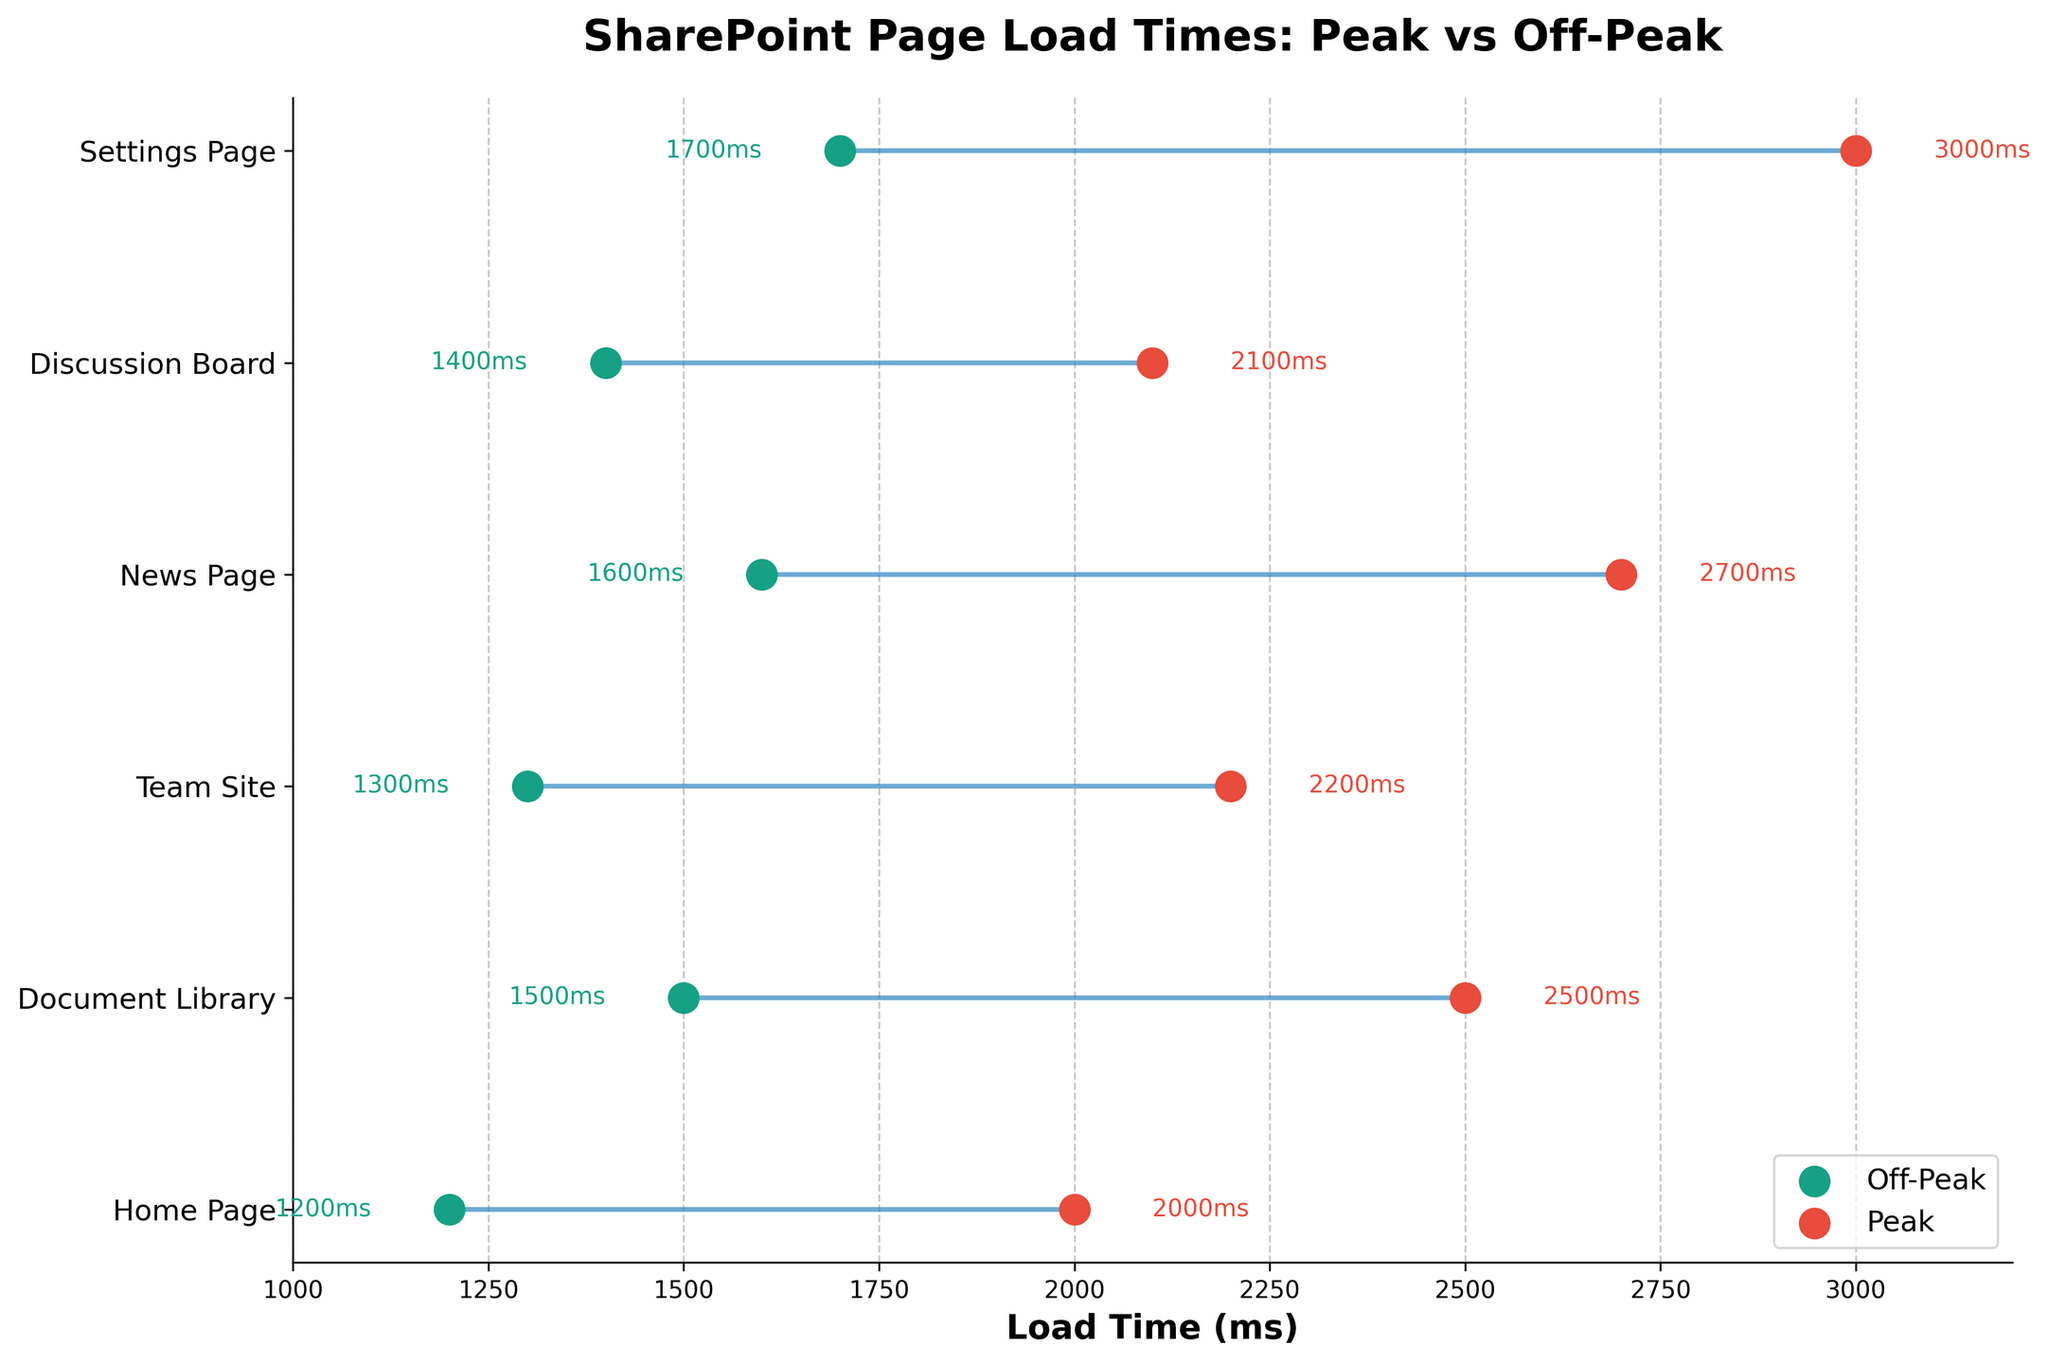How many pages are displayed on the plot? Count the number of distinct page names on the y-axis of the plot.
Answer: 6 What is the title of the plot? Look at the top of the plot where titles are typically placed.
Answer: "SharePoint Page Load Times: Peak vs Off-Peak" Which page has the maximum load time during peak hours? Identify the highest value on the x-axis for the red points (representing peak times) and check the corresponding page name on the y-axis.
Answer: "Settings Page" What is the difference in load time between peak and off-peak hours for the Home Page? Subtract the off-peak time from the peak time for the Home Page: 2000ms - 1200ms.
Answer: 800ms Arrange the pages in descending order of their off-peak load times. Compare the off-peak load times for all pages and sort them from highest to lowest.
Answer: Settings Page, News Page, Document Library, Discussion Board, Team Site, Home Page Which page shows the smallest difference between peak and off-peak load times? Calculate the difference between peak and off-peak times for each page and identify the smallest difference.
Answer: "Home Page" Are there any pages where the load time during peak hours is double or more compared to off-peak hours? Check each page to see if the peak time is at least twice the off-peak time.
Answer: No What is the average load time during off-peak hours across all pages? Add up the off-peak load times and divide by the number of pages: (1200 + 1500 + 1300 + 1600 + 1400 + 1700) / 6.
Answer: 1450ms Which page has a load time of 2200ms during peak hours? Look for the red point that reads 2200ms and identify its corresponding page name.
Answer: "Team Site" 